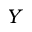<formula> <loc_0><loc_0><loc_500><loc_500>Y</formula> 